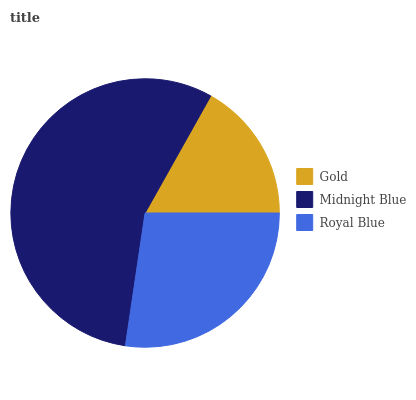Is Gold the minimum?
Answer yes or no. Yes. Is Midnight Blue the maximum?
Answer yes or no. Yes. Is Royal Blue the minimum?
Answer yes or no. No. Is Royal Blue the maximum?
Answer yes or no. No. Is Midnight Blue greater than Royal Blue?
Answer yes or no. Yes. Is Royal Blue less than Midnight Blue?
Answer yes or no. Yes. Is Royal Blue greater than Midnight Blue?
Answer yes or no. No. Is Midnight Blue less than Royal Blue?
Answer yes or no. No. Is Royal Blue the high median?
Answer yes or no. Yes. Is Royal Blue the low median?
Answer yes or no. Yes. Is Midnight Blue the high median?
Answer yes or no. No. Is Gold the low median?
Answer yes or no. No. 